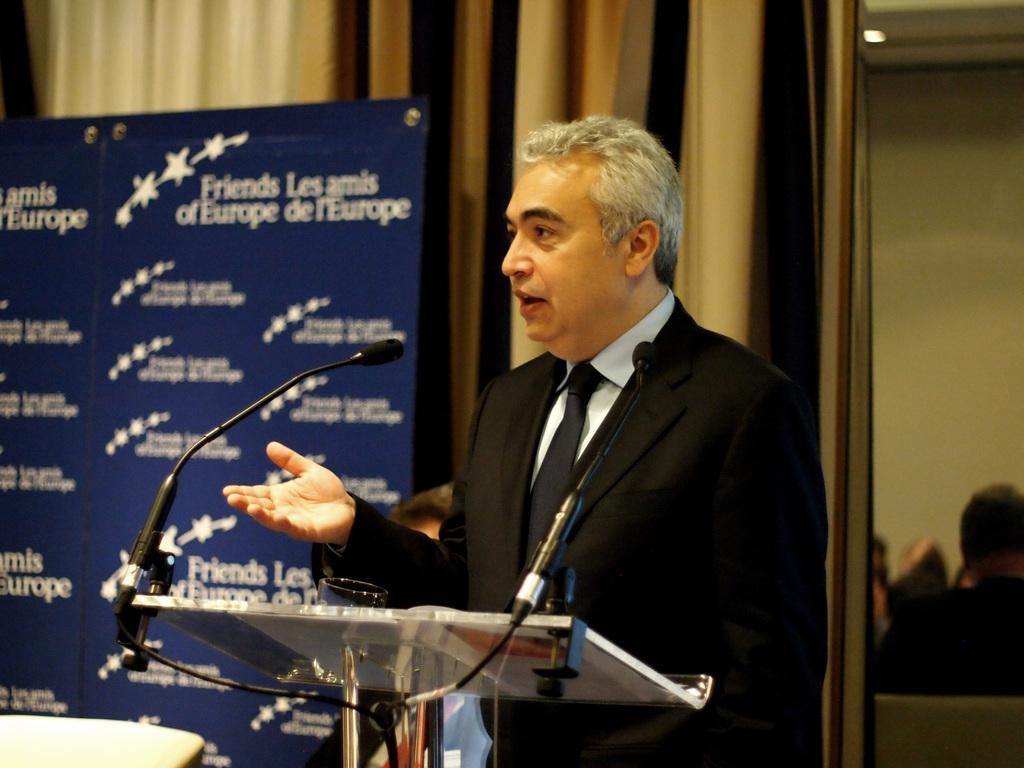Could you give a brief overview of what you see in this image? In the picture I can see a person wearing blazer, tie and shirt is standing at the podium where glass and mics are placed. The background of the image is blurred, where we can see a board which is in blue color on which we can see some text and we can see the curtains. 